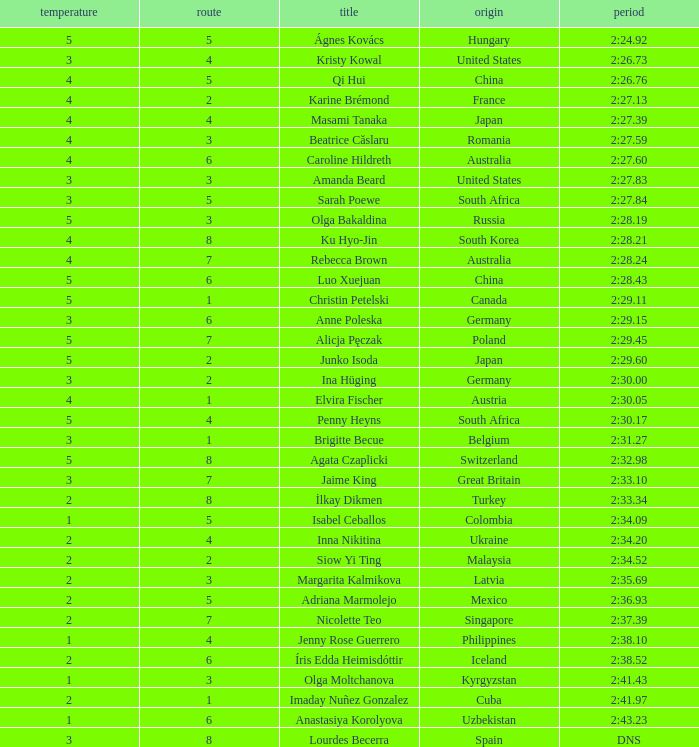What is the title that observed 4 temperature increases and a route greater than 7? Ku Hyo-Jin. 